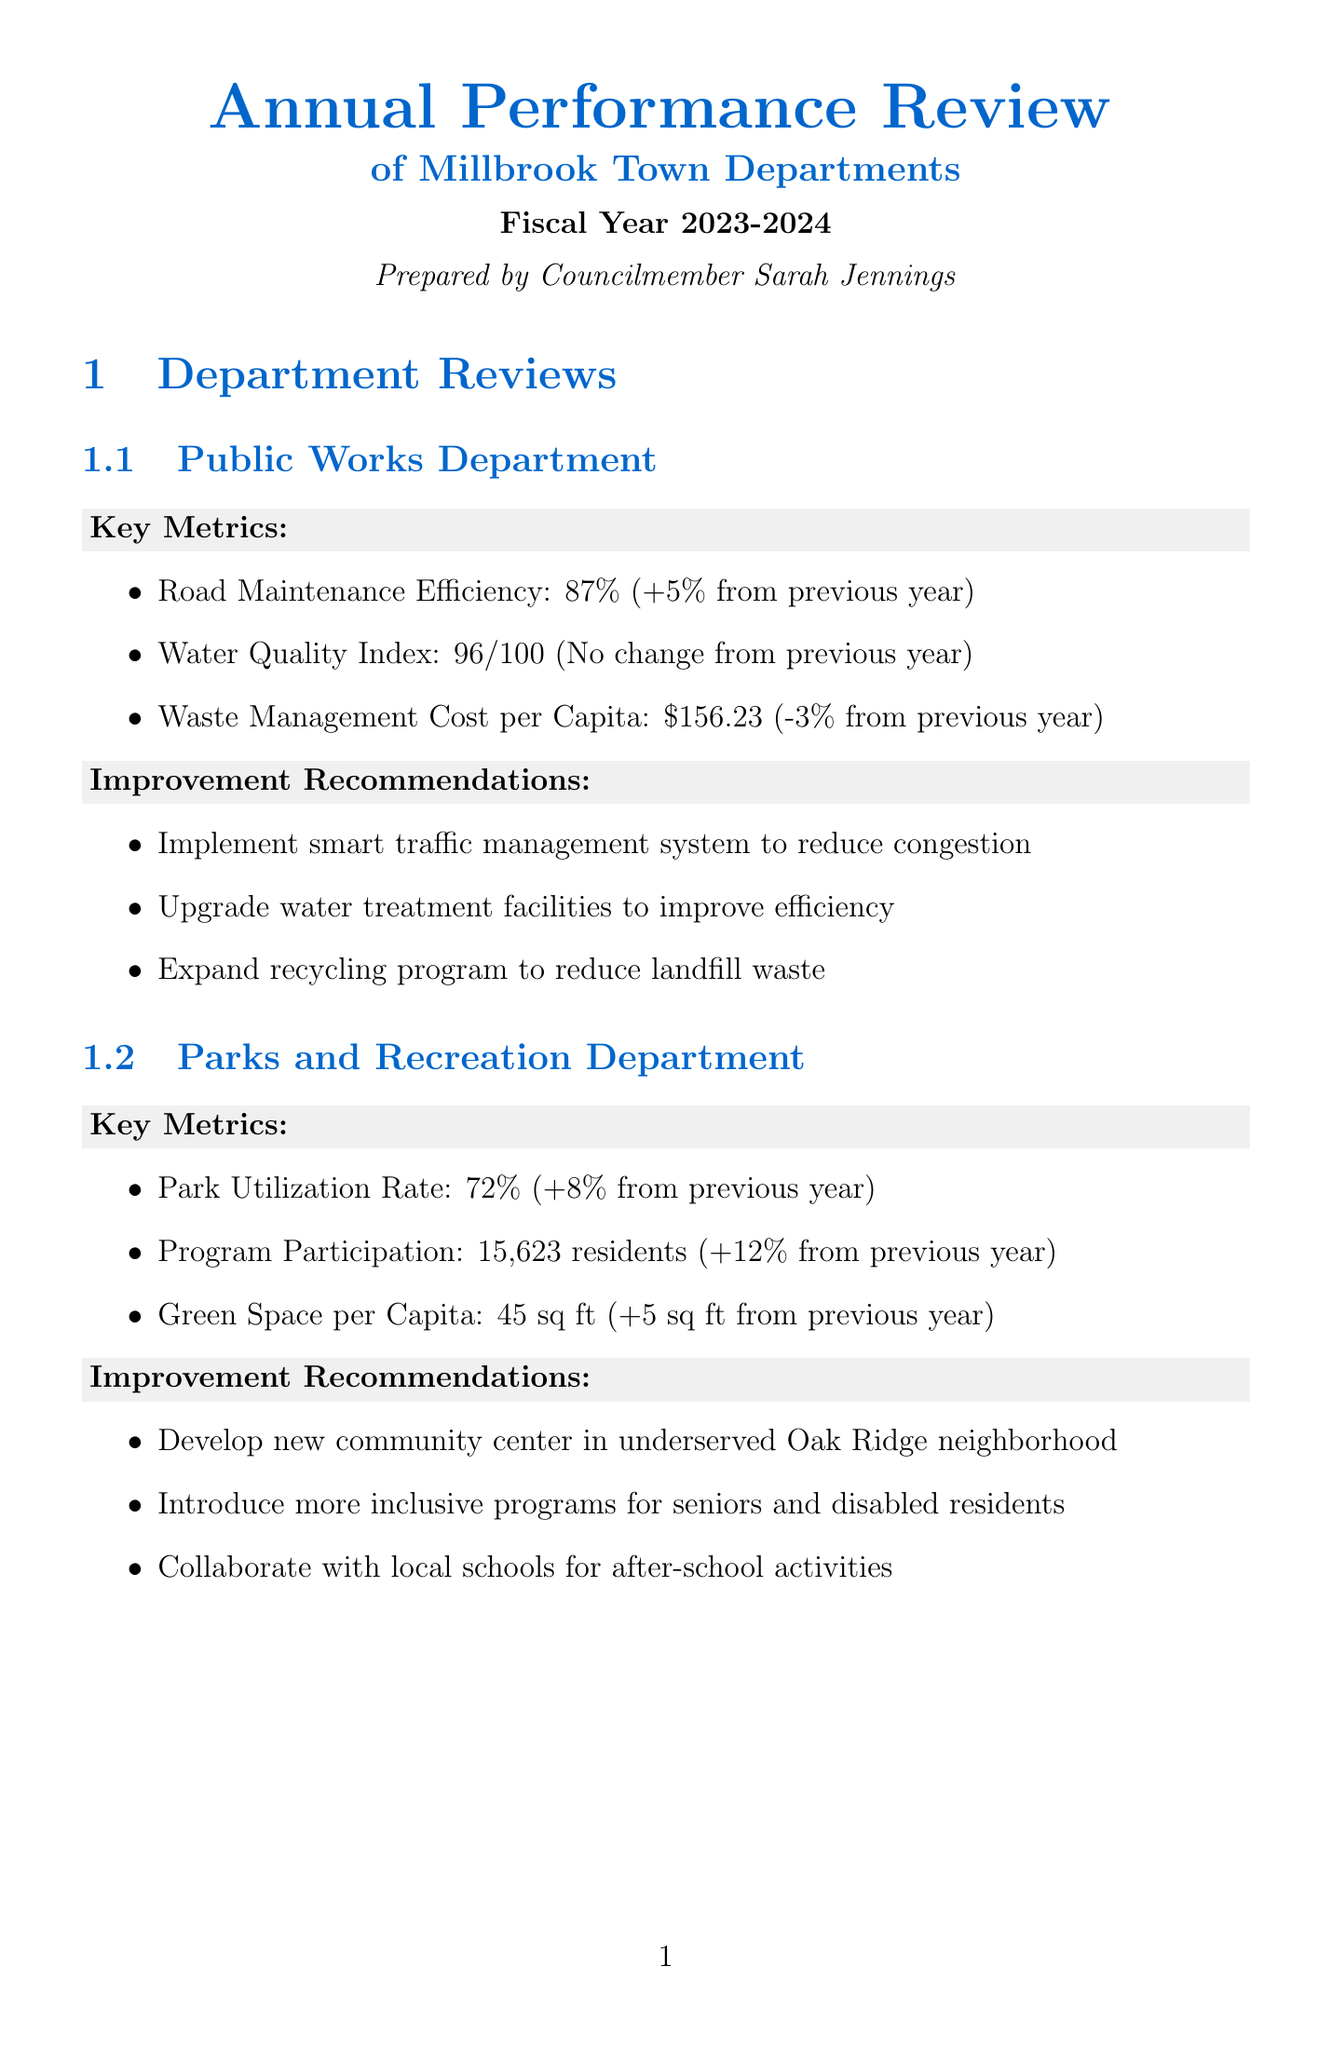what is the rating of town performance? The rating of town performance is given in the Overall Town Performance section of the document.
Answer: Excellent what is the waste management cost per capita? The waste management cost per capita is a key metric listed under the Public Works Department.
Answer: $156.23 how many community engagement events were held by the Police Department? The number of community engagement events is mentioned as a key metric for the Police Department.
Answer: 87 which department had the highest increase in program participation? The department with the highest increase in program participation can be determined by comparing the percentages listed in the Parks and Recreation Department.
Answer: Parks and Recreation Department what is one of the improvement recommendations for the Finance Department? Improvement recommendations for the Finance Department are listed in the document that relates to enhancing service delivery.
Answer: Implement online payment system for all town services what was the change in the Crime Rate? The change in the Crime Rate is indicated as a key metric for the Police Department.
Answer: -0.3 from previous year what is one challenge ahead for the town? Challenges ahead for the town are listed in the Overall Town Performance section.
Answer: Addressing aging infrastructure in certain neighborhoods who prepared the report? The document includes information about its preparation, specifically who compiled the information.
Answer: Councilmember Sarah Jennings 